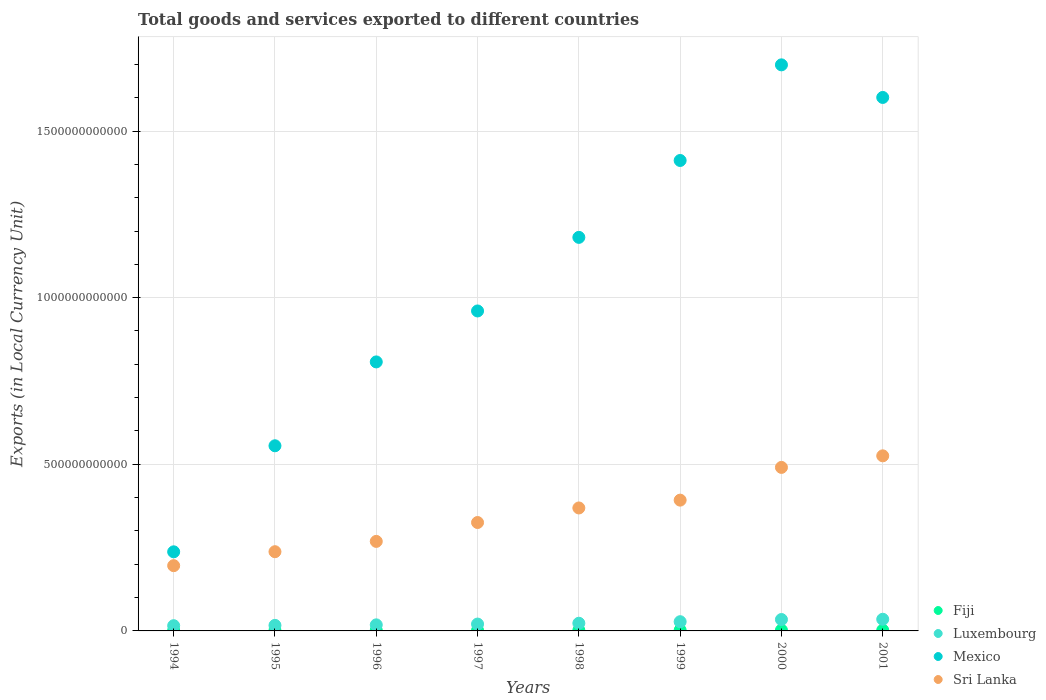How many different coloured dotlines are there?
Give a very brief answer. 4. Is the number of dotlines equal to the number of legend labels?
Keep it short and to the point. Yes. What is the Amount of goods and services exports in Sri Lanka in 2000?
Give a very brief answer. 4.91e+11. Across all years, what is the maximum Amount of goods and services exports in Fiji?
Provide a succinct answer. 2.34e+09. Across all years, what is the minimum Amount of goods and services exports in Fiji?
Make the answer very short. 1.51e+09. In which year was the Amount of goods and services exports in Mexico maximum?
Keep it short and to the point. 2000. In which year was the Amount of goods and services exports in Mexico minimum?
Make the answer very short. 1994. What is the total Amount of goods and services exports in Luxembourg in the graph?
Make the answer very short. 1.91e+11. What is the difference between the Amount of goods and services exports in Luxembourg in 1995 and that in 1999?
Ensure brevity in your answer.  -1.10e+1. What is the difference between the Amount of goods and services exports in Sri Lanka in 1995 and the Amount of goods and services exports in Mexico in 2000?
Provide a short and direct response. -1.46e+12. What is the average Amount of goods and services exports in Fiji per year?
Offer a very short reply. 1.98e+09. In the year 1994, what is the difference between the Amount of goods and services exports in Sri Lanka and Amount of goods and services exports in Mexico?
Your answer should be compact. -4.16e+1. What is the ratio of the Amount of goods and services exports in Mexico in 1996 to that in 2001?
Keep it short and to the point. 0.5. What is the difference between the highest and the second highest Amount of goods and services exports in Sri Lanka?
Provide a short and direct response. 3.47e+1. What is the difference between the highest and the lowest Amount of goods and services exports in Fiji?
Give a very brief answer. 8.28e+08. Is it the case that in every year, the sum of the Amount of goods and services exports in Luxembourg and Amount of goods and services exports in Sri Lanka  is greater than the sum of Amount of goods and services exports in Fiji and Amount of goods and services exports in Mexico?
Your response must be concise. No. Is it the case that in every year, the sum of the Amount of goods and services exports in Luxembourg and Amount of goods and services exports in Mexico  is greater than the Amount of goods and services exports in Sri Lanka?
Your response must be concise. Yes. Does the Amount of goods and services exports in Luxembourg monotonically increase over the years?
Provide a short and direct response. Yes. How many dotlines are there?
Give a very brief answer. 4. What is the difference between two consecutive major ticks on the Y-axis?
Ensure brevity in your answer.  5.00e+11. How many legend labels are there?
Ensure brevity in your answer.  4. What is the title of the graph?
Your answer should be very brief. Total goods and services exported to different countries. What is the label or title of the Y-axis?
Provide a succinct answer. Exports (in Local Currency Unit). What is the Exports (in Local Currency Unit) of Fiji in 1994?
Provide a short and direct response. 1.51e+09. What is the Exports (in Local Currency Unit) in Luxembourg in 1994?
Your answer should be very brief. 1.57e+1. What is the Exports (in Local Currency Unit) of Mexico in 1994?
Ensure brevity in your answer.  2.37e+11. What is the Exports (in Local Currency Unit) of Sri Lanka in 1994?
Your answer should be compact. 1.96e+11. What is the Exports (in Local Currency Unit) in Fiji in 1995?
Your response must be concise. 1.64e+09. What is the Exports (in Local Currency Unit) of Luxembourg in 1995?
Make the answer very short. 1.67e+1. What is the Exports (in Local Currency Unit) in Mexico in 1995?
Make the answer very short. 5.56e+11. What is the Exports (in Local Currency Unit) of Sri Lanka in 1995?
Your answer should be compact. 2.38e+11. What is the Exports (in Local Currency Unit) in Fiji in 1996?
Provide a succinct answer. 1.88e+09. What is the Exports (in Local Currency Unit) in Luxembourg in 1996?
Your response must be concise. 1.82e+1. What is the Exports (in Local Currency Unit) in Mexico in 1996?
Keep it short and to the point. 8.07e+11. What is the Exports (in Local Currency Unit) in Sri Lanka in 1996?
Your answer should be compact. 2.69e+11. What is the Exports (in Local Currency Unit) in Fiji in 1997?
Ensure brevity in your answer.  1.85e+09. What is the Exports (in Local Currency Unit) of Luxembourg in 1997?
Provide a short and direct response. 2.06e+1. What is the Exports (in Local Currency Unit) in Mexico in 1997?
Your answer should be very brief. 9.60e+11. What is the Exports (in Local Currency Unit) of Sri Lanka in 1997?
Give a very brief answer. 3.25e+11. What is the Exports (in Local Currency Unit) of Fiji in 1998?
Ensure brevity in your answer.  2.00e+09. What is the Exports (in Local Currency Unit) in Luxembourg in 1998?
Provide a short and direct response. 2.30e+1. What is the Exports (in Local Currency Unit) of Mexico in 1998?
Your response must be concise. 1.18e+12. What is the Exports (in Local Currency Unit) of Sri Lanka in 1998?
Make the answer very short. 3.69e+11. What is the Exports (in Local Currency Unit) of Fiji in 1999?
Offer a very short reply. 2.33e+09. What is the Exports (in Local Currency Unit) in Luxembourg in 1999?
Give a very brief answer. 2.77e+1. What is the Exports (in Local Currency Unit) of Mexico in 1999?
Provide a short and direct response. 1.41e+12. What is the Exports (in Local Currency Unit) of Sri Lanka in 1999?
Your answer should be compact. 3.92e+11. What is the Exports (in Local Currency Unit) of Fiji in 2000?
Ensure brevity in your answer.  2.34e+09. What is the Exports (in Local Currency Unit) of Luxembourg in 2000?
Ensure brevity in your answer.  3.42e+1. What is the Exports (in Local Currency Unit) in Mexico in 2000?
Ensure brevity in your answer.  1.70e+12. What is the Exports (in Local Currency Unit) of Sri Lanka in 2000?
Make the answer very short. 4.91e+11. What is the Exports (in Local Currency Unit) in Fiji in 2001?
Ensure brevity in your answer.  2.29e+09. What is the Exports (in Local Currency Unit) of Luxembourg in 2001?
Keep it short and to the point. 3.50e+1. What is the Exports (in Local Currency Unit) in Mexico in 2001?
Ensure brevity in your answer.  1.60e+12. What is the Exports (in Local Currency Unit) of Sri Lanka in 2001?
Your response must be concise. 5.25e+11. Across all years, what is the maximum Exports (in Local Currency Unit) of Fiji?
Provide a succinct answer. 2.34e+09. Across all years, what is the maximum Exports (in Local Currency Unit) of Luxembourg?
Offer a terse response. 3.50e+1. Across all years, what is the maximum Exports (in Local Currency Unit) of Mexico?
Provide a succinct answer. 1.70e+12. Across all years, what is the maximum Exports (in Local Currency Unit) in Sri Lanka?
Make the answer very short. 5.25e+11. Across all years, what is the minimum Exports (in Local Currency Unit) in Fiji?
Give a very brief answer. 1.51e+09. Across all years, what is the minimum Exports (in Local Currency Unit) of Luxembourg?
Offer a terse response. 1.57e+1. Across all years, what is the minimum Exports (in Local Currency Unit) of Mexico?
Your answer should be compact. 2.37e+11. Across all years, what is the minimum Exports (in Local Currency Unit) of Sri Lanka?
Keep it short and to the point. 1.96e+11. What is the total Exports (in Local Currency Unit) of Fiji in the graph?
Ensure brevity in your answer.  1.58e+1. What is the total Exports (in Local Currency Unit) in Luxembourg in the graph?
Offer a very short reply. 1.91e+11. What is the total Exports (in Local Currency Unit) of Mexico in the graph?
Give a very brief answer. 8.45e+12. What is the total Exports (in Local Currency Unit) of Sri Lanka in the graph?
Provide a succinct answer. 2.80e+12. What is the difference between the Exports (in Local Currency Unit) of Fiji in 1994 and that in 1995?
Provide a short and direct response. -1.35e+08. What is the difference between the Exports (in Local Currency Unit) of Luxembourg in 1994 and that in 1995?
Make the answer very short. -9.69e+08. What is the difference between the Exports (in Local Currency Unit) of Mexico in 1994 and that in 1995?
Your answer should be very brief. -3.18e+11. What is the difference between the Exports (in Local Currency Unit) in Sri Lanka in 1994 and that in 1995?
Offer a terse response. -4.19e+1. What is the difference between the Exports (in Local Currency Unit) in Fiji in 1994 and that in 1996?
Keep it short and to the point. -3.70e+08. What is the difference between the Exports (in Local Currency Unit) in Luxembourg in 1994 and that in 1996?
Make the answer very short. -2.50e+09. What is the difference between the Exports (in Local Currency Unit) of Mexico in 1994 and that in 1996?
Offer a very short reply. -5.70e+11. What is the difference between the Exports (in Local Currency Unit) in Sri Lanka in 1994 and that in 1996?
Provide a short and direct response. -7.28e+1. What is the difference between the Exports (in Local Currency Unit) of Fiji in 1994 and that in 1997?
Provide a short and direct response. -3.38e+08. What is the difference between the Exports (in Local Currency Unit) of Luxembourg in 1994 and that in 1997?
Give a very brief answer. -4.89e+09. What is the difference between the Exports (in Local Currency Unit) of Mexico in 1994 and that in 1997?
Your response must be concise. -7.23e+11. What is the difference between the Exports (in Local Currency Unit) in Sri Lanka in 1994 and that in 1997?
Offer a very short reply. -1.29e+11. What is the difference between the Exports (in Local Currency Unit) in Fiji in 1994 and that in 1998?
Offer a very short reply. -4.94e+08. What is the difference between the Exports (in Local Currency Unit) in Luxembourg in 1994 and that in 1998?
Give a very brief answer. -7.32e+09. What is the difference between the Exports (in Local Currency Unit) of Mexico in 1994 and that in 1998?
Keep it short and to the point. -9.44e+11. What is the difference between the Exports (in Local Currency Unit) in Sri Lanka in 1994 and that in 1998?
Your response must be concise. -1.73e+11. What is the difference between the Exports (in Local Currency Unit) in Fiji in 1994 and that in 1999?
Give a very brief answer. -8.26e+08. What is the difference between the Exports (in Local Currency Unit) in Luxembourg in 1994 and that in 1999?
Keep it short and to the point. -1.20e+1. What is the difference between the Exports (in Local Currency Unit) of Mexico in 1994 and that in 1999?
Ensure brevity in your answer.  -1.17e+12. What is the difference between the Exports (in Local Currency Unit) in Sri Lanka in 1994 and that in 1999?
Provide a short and direct response. -1.97e+11. What is the difference between the Exports (in Local Currency Unit) in Fiji in 1994 and that in 2000?
Provide a short and direct response. -8.28e+08. What is the difference between the Exports (in Local Currency Unit) in Luxembourg in 1994 and that in 2000?
Make the answer very short. -1.85e+1. What is the difference between the Exports (in Local Currency Unit) in Mexico in 1994 and that in 2000?
Provide a succinct answer. -1.46e+12. What is the difference between the Exports (in Local Currency Unit) in Sri Lanka in 1994 and that in 2000?
Offer a terse response. -2.95e+11. What is the difference between the Exports (in Local Currency Unit) in Fiji in 1994 and that in 2001?
Offer a terse response. -7.85e+08. What is the difference between the Exports (in Local Currency Unit) in Luxembourg in 1994 and that in 2001?
Your answer should be compact. -1.93e+1. What is the difference between the Exports (in Local Currency Unit) in Mexico in 1994 and that in 2001?
Provide a succinct answer. -1.36e+12. What is the difference between the Exports (in Local Currency Unit) of Sri Lanka in 1994 and that in 2001?
Offer a terse response. -3.30e+11. What is the difference between the Exports (in Local Currency Unit) of Fiji in 1995 and that in 1996?
Provide a succinct answer. -2.35e+08. What is the difference between the Exports (in Local Currency Unit) of Luxembourg in 1995 and that in 1996?
Give a very brief answer. -1.53e+09. What is the difference between the Exports (in Local Currency Unit) in Mexico in 1995 and that in 1996?
Offer a terse response. -2.52e+11. What is the difference between the Exports (in Local Currency Unit) of Sri Lanka in 1995 and that in 1996?
Make the answer very short. -3.09e+1. What is the difference between the Exports (in Local Currency Unit) of Fiji in 1995 and that in 1997?
Give a very brief answer. -2.02e+08. What is the difference between the Exports (in Local Currency Unit) of Luxembourg in 1995 and that in 1997?
Provide a succinct answer. -3.92e+09. What is the difference between the Exports (in Local Currency Unit) in Mexico in 1995 and that in 1997?
Your answer should be very brief. -4.05e+11. What is the difference between the Exports (in Local Currency Unit) in Sri Lanka in 1995 and that in 1997?
Keep it short and to the point. -8.76e+1. What is the difference between the Exports (in Local Currency Unit) in Fiji in 1995 and that in 1998?
Offer a very short reply. -3.59e+08. What is the difference between the Exports (in Local Currency Unit) in Luxembourg in 1995 and that in 1998?
Make the answer very short. -6.36e+09. What is the difference between the Exports (in Local Currency Unit) in Mexico in 1995 and that in 1998?
Make the answer very short. -6.25e+11. What is the difference between the Exports (in Local Currency Unit) in Sri Lanka in 1995 and that in 1998?
Provide a succinct answer. -1.31e+11. What is the difference between the Exports (in Local Currency Unit) in Fiji in 1995 and that in 1999?
Your answer should be compact. -6.91e+08. What is the difference between the Exports (in Local Currency Unit) in Luxembourg in 1995 and that in 1999?
Ensure brevity in your answer.  -1.10e+1. What is the difference between the Exports (in Local Currency Unit) in Mexico in 1995 and that in 1999?
Offer a very short reply. -8.56e+11. What is the difference between the Exports (in Local Currency Unit) in Sri Lanka in 1995 and that in 1999?
Ensure brevity in your answer.  -1.55e+11. What is the difference between the Exports (in Local Currency Unit) of Fiji in 1995 and that in 2000?
Provide a succinct answer. -6.93e+08. What is the difference between the Exports (in Local Currency Unit) in Luxembourg in 1995 and that in 2000?
Ensure brevity in your answer.  -1.75e+1. What is the difference between the Exports (in Local Currency Unit) in Mexico in 1995 and that in 2000?
Offer a very short reply. -1.14e+12. What is the difference between the Exports (in Local Currency Unit) of Sri Lanka in 1995 and that in 2000?
Make the answer very short. -2.53e+11. What is the difference between the Exports (in Local Currency Unit) of Fiji in 1995 and that in 2001?
Your response must be concise. -6.50e+08. What is the difference between the Exports (in Local Currency Unit) of Luxembourg in 1995 and that in 2001?
Your answer should be very brief. -1.83e+1. What is the difference between the Exports (in Local Currency Unit) of Mexico in 1995 and that in 2001?
Ensure brevity in your answer.  -1.05e+12. What is the difference between the Exports (in Local Currency Unit) of Sri Lanka in 1995 and that in 2001?
Offer a terse response. -2.88e+11. What is the difference between the Exports (in Local Currency Unit) of Fiji in 1996 and that in 1997?
Keep it short and to the point. 3.26e+07. What is the difference between the Exports (in Local Currency Unit) in Luxembourg in 1996 and that in 1997?
Give a very brief answer. -2.38e+09. What is the difference between the Exports (in Local Currency Unit) in Mexico in 1996 and that in 1997?
Keep it short and to the point. -1.53e+11. What is the difference between the Exports (in Local Currency Unit) in Sri Lanka in 1996 and that in 1997?
Give a very brief answer. -5.66e+1. What is the difference between the Exports (in Local Currency Unit) of Fiji in 1996 and that in 1998?
Your answer should be very brief. -1.24e+08. What is the difference between the Exports (in Local Currency Unit) in Luxembourg in 1996 and that in 1998?
Give a very brief answer. -4.82e+09. What is the difference between the Exports (in Local Currency Unit) of Mexico in 1996 and that in 1998?
Give a very brief answer. -3.74e+11. What is the difference between the Exports (in Local Currency Unit) of Sri Lanka in 1996 and that in 1998?
Ensure brevity in your answer.  -1.00e+11. What is the difference between the Exports (in Local Currency Unit) of Fiji in 1996 and that in 1999?
Make the answer very short. -4.56e+08. What is the difference between the Exports (in Local Currency Unit) in Luxembourg in 1996 and that in 1999?
Your answer should be compact. -9.48e+09. What is the difference between the Exports (in Local Currency Unit) in Mexico in 1996 and that in 1999?
Give a very brief answer. -6.04e+11. What is the difference between the Exports (in Local Currency Unit) in Sri Lanka in 1996 and that in 1999?
Make the answer very short. -1.24e+11. What is the difference between the Exports (in Local Currency Unit) in Fiji in 1996 and that in 2000?
Provide a succinct answer. -4.58e+08. What is the difference between the Exports (in Local Currency Unit) in Luxembourg in 1996 and that in 2000?
Make the answer very short. -1.60e+1. What is the difference between the Exports (in Local Currency Unit) in Mexico in 1996 and that in 2000?
Provide a succinct answer. -8.91e+11. What is the difference between the Exports (in Local Currency Unit) in Sri Lanka in 1996 and that in 2000?
Make the answer very short. -2.22e+11. What is the difference between the Exports (in Local Currency Unit) in Fiji in 1996 and that in 2001?
Ensure brevity in your answer.  -4.15e+08. What is the difference between the Exports (in Local Currency Unit) of Luxembourg in 1996 and that in 2001?
Provide a succinct answer. -1.68e+1. What is the difference between the Exports (in Local Currency Unit) in Mexico in 1996 and that in 2001?
Keep it short and to the point. -7.94e+11. What is the difference between the Exports (in Local Currency Unit) of Sri Lanka in 1996 and that in 2001?
Make the answer very short. -2.57e+11. What is the difference between the Exports (in Local Currency Unit) of Fiji in 1997 and that in 1998?
Keep it short and to the point. -1.56e+08. What is the difference between the Exports (in Local Currency Unit) of Luxembourg in 1997 and that in 1998?
Provide a short and direct response. -2.44e+09. What is the difference between the Exports (in Local Currency Unit) in Mexico in 1997 and that in 1998?
Provide a short and direct response. -2.21e+11. What is the difference between the Exports (in Local Currency Unit) of Sri Lanka in 1997 and that in 1998?
Make the answer very short. -4.37e+1. What is the difference between the Exports (in Local Currency Unit) of Fiji in 1997 and that in 1999?
Your answer should be compact. -4.89e+08. What is the difference between the Exports (in Local Currency Unit) of Luxembourg in 1997 and that in 1999?
Your answer should be compact. -7.10e+09. What is the difference between the Exports (in Local Currency Unit) of Mexico in 1997 and that in 1999?
Provide a succinct answer. -4.52e+11. What is the difference between the Exports (in Local Currency Unit) of Sri Lanka in 1997 and that in 1999?
Ensure brevity in your answer.  -6.71e+1. What is the difference between the Exports (in Local Currency Unit) in Fiji in 1997 and that in 2000?
Keep it short and to the point. -4.90e+08. What is the difference between the Exports (in Local Currency Unit) of Luxembourg in 1997 and that in 2000?
Your answer should be compact. -1.36e+1. What is the difference between the Exports (in Local Currency Unit) in Mexico in 1997 and that in 2000?
Keep it short and to the point. -7.38e+11. What is the difference between the Exports (in Local Currency Unit) in Sri Lanka in 1997 and that in 2000?
Offer a terse response. -1.65e+11. What is the difference between the Exports (in Local Currency Unit) in Fiji in 1997 and that in 2001?
Provide a succinct answer. -4.48e+08. What is the difference between the Exports (in Local Currency Unit) of Luxembourg in 1997 and that in 2001?
Offer a terse response. -1.44e+1. What is the difference between the Exports (in Local Currency Unit) of Mexico in 1997 and that in 2001?
Your answer should be compact. -6.41e+11. What is the difference between the Exports (in Local Currency Unit) of Sri Lanka in 1997 and that in 2001?
Offer a very short reply. -2.00e+11. What is the difference between the Exports (in Local Currency Unit) in Fiji in 1998 and that in 1999?
Provide a succinct answer. -3.33e+08. What is the difference between the Exports (in Local Currency Unit) of Luxembourg in 1998 and that in 1999?
Give a very brief answer. -4.66e+09. What is the difference between the Exports (in Local Currency Unit) of Mexico in 1998 and that in 1999?
Keep it short and to the point. -2.31e+11. What is the difference between the Exports (in Local Currency Unit) of Sri Lanka in 1998 and that in 1999?
Offer a terse response. -2.35e+1. What is the difference between the Exports (in Local Currency Unit) of Fiji in 1998 and that in 2000?
Your answer should be compact. -3.34e+08. What is the difference between the Exports (in Local Currency Unit) in Luxembourg in 1998 and that in 2000?
Provide a short and direct response. -1.12e+1. What is the difference between the Exports (in Local Currency Unit) of Mexico in 1998 and that in 2000?
Give a very brief answer. -5.18e+11. What is the difference between the Exports (in Local Currency Unit) of Sri Lanka in 1998 and that in 2000?
Provide a succinct answer. -1.22e+11. What is the difference between the Exports (in Local Currency Unit) of Fiji in 1998 and that in 2001?
Your response must be concise. -2.92e+08. What is the difference between the Exports (in Local Currency Unit) of Luxembourg in 1998 and that in 2001?
Your answer should be compact. -1.20e+1. What is the difference between the Exports (in Local Currency Unit) in Mexico in 1998 and that in 2001?
Provide a short and direct response. -4.20e+11. What is the difference between the Exports (in Local Currency Unit) of Sri Lanka in 1998 and that in 2001?
Offer a very short reply. -1.56e+11. What is the difference between the Exports (in Local Currency Unit) of Fiji in 1999 and that in 2000?
Keep it short and to the point. -1.50e+06. What is the difference between the Exports (in Local Currency Unit) of Luxembourg in 1999 and that in 2000?
Provide a succinct answer. -6.53e+09. What is the difference between the Exports (in Local Currency Unit) in Mexico in 1999 and that in 2000?
Your answer should be compact. -2.87e+11. What is the difference between the Exports (in Local Currency Unit) in Sri Lanka in 1999 and that in 2000?
Your answer should be compact. -9.82e+1. What is the difference between the Exports (in Local Currency Unit) in Fiji in 1999 and that in 2001?
Keep it short and to the point. 4.12e+07. What is the difference between the Exports (in Local Currency Unit) of Luxembourg in 1999 and that in 2001?
Offer a terse response. -7.30e+09. What is the difference between the Exports (in Local Currency Unit) of Mexico in 1999 and that in 2001?
Ensure brevity in your answer.  -1.89e+11. What is the difference between the Exports (in Local Currency Unit) in Sri Lanka in 1999 and that in 2001?
Provide a short and direct response. -1.33e+11. What is the difference between the Exports (in Local Currency Unit) in Fiji in 2000 and that in 2001?
Give a very brief answer. 4.27e+07. What is the difference between the Exports (in Local Currency Unit) in Luxembourg in 2000 and that in 2001?
Your answer should be compact. -7.67e+08. What is the difference between the Exports (in Local Currency Unit) of Mexico in 2000 and that in 2001?
Offer a very short reply. 9.78e+1. What is the difference between the Exports (in Local Currency Unit) of Sri Lanka in 2000 and that in 2001?
Your response must be concise. -3.47e+1. What is the difference between the Exports (in Local Currency Unit) in Fiji in 1994 and the Exports (in Local Currency Unit) in Luxembourg in 1995?
Give a very brief answer. -1.52e+1. What is the difference between the Exports (in Local Currency Unit) in Fiji in 1994 and the Exports (in Local Currency Unit) in Mexico in 1995?
Your answer should be compact. -5.54e+11. What is the difference between the Exports (in Local Currency Unit) of Fiji in 1994 and the Exports (in Local Currency Unit) of Sri Lanka in 1995?
Your answer should be compact. -2.36e+11. What is the difference between the Exports (in Local Currency Unit) in Luxembourg in 1994 and the Exports (in Local Currency Unit) in Mexico in 1995?
Provide a short and direct response. -5.40e+11. What is the difference between the Exports (in Local Currency Unit) in Luxembourg in 1994 and the Exports (in Local Currency Unit) in Sri Lanka in 1995?
Offer a terse response. -2.22e+11. What is the difference between the Exports (in Local Currency Unit) of Mexico in 1994 and the Exports (in Local Currency Unit) of Sri Lanka in 1995?
Give a very brief answer. -3.53e+08. What is the difference between the Exports (in Local Currency Unit) in Fiji in 1994 and the Exports (in Local Currency Unit) in Luxembourg in 1996?
Your answer should be compact. -1.67e+1. What is the difference between the Exports (in Local Currency Unit) in Fiji in 1994 and the Exports (in Local Currency Unit) in Mexico in 1996?
Ensure brevity in your answer.  -8.06e+11. What is the difference between the Exports (in Local Currency Unit) in Fiji in 1994 and the Exports (in Local Currency Unit) in Sri Lanka in 1996?
Provide a short and direct response. -2.67e+11. What is the difference between the Exports (in Local Currency Unit) in Luxembourg in 1994 and the Exports (in Local Currency Unit) in Mexico in 1996?
Your response must be concise. -7.92e+11. What is the difference between the Exports (in Local Currency Unit) in Luxembourg in 1994 and the Exports (in Local Currency Unit) in Sri Lanka in 1996?
Provide a succinct answer. -2.53e+11. What is the difference between the Exports (in Local Currency Unit) of Mexico in 1994 and the Exports (in Local Currency Unit) of Sri Lanka in 1996?
Offer a terse response. -3.13e+1. What is the difference between the Exports (in Local Currency Unit) in Fiji in 1994 and the Exports (in Local Currency Unit) in Luxembourg in 1997?
Your answer should be compact. -1.91e+1. What is the difference between the Exports (in Local Currency Unit) of Fiji in 1994 and the Exports (in Local Currency Unit) of Mexico in 1997?
Keep it short and to the point. -9.59e+11. What is the difference between the Exports (in Local Currency Unit) in Fiji in 1994 and the Exports (in Local Currency Unit) in Sri Lanka in 1997?
Offer a terse response. -3.24e+11. What is the difference between the Exports (in Local Currency Unit) in Luxembourg in 1994 and the Exports (in Local Currency Unit) in Mexico in 1997?
Offer a very short reply. -9.44e+11. What is the difference between the Exports (in Local Currency Unit) in Luxembourg in 1994 and the Exports (in Local Currency Unit) in Sri Lanka in 1997?
Your answer should be very brief. -3.10e+11. What is the difference between the Exports (in Local Currency Unit) of Mexico in 1994 and the Exports (in Local Currency Unit) of Sri Lanka in 1997?
Your response must be concise. -8.79e+1. What is the difference between the Exports (in Local Currency Unit) in Fiji in 1994 and the Exports (in Local Currency Unit) in Luxembourg in 1998?
Provide a succinct answer. -2.15e+1. What is the difference between the Exports (in Local Currency Unit) of Fiji in 1994 and the Exports (in Local Currency Unit) of Mexico in 1998?
Give a very brief answer. -1.18e+12. What is the difference between the Exports (in Local Currency Unit) of Fiji in 1994 and the Exports (in Local Currency Unit) of Sri Lanka in 1998?
Your response must be concise. -3.67e+11. What is the difference between the Exports (in Local Currency Unit) of Luxembourg in 1994 and the Exports (in Local Currency Unit) of Mexico in 1998?
Offer a very short reply. -1.17e+12. What is the difference between the Exports (in Local Currency Unit) in Luxembourg in 1994 and the Exports (in Local Currency Unit) in Sri Lanka in 1998?
Your answer should be very brief. -3.53e+11. What is the difference between the Exports (in Local Currency Unit) of Mexico in 1994 and the Exports (in Local Currency Unit) of Sri Lanka in 1998?
Keep it short and to the point. -1.32e+11. What is the difference between the Exports (in Local Currency Unit) in Fiji in 1994 and the Exports (in Local Currency Unit) in Luxembourg in 1999?
Your answer should be very brief. -2.62e+1. What is the difference between the Exports (in Local Currency Unit) of Fiji in 1994 and the Exports (in Local Currency Unit) of Mexico in 1999?
Provide a short and direct response. -1.41e+12. What is the difference between the Exports (in Local Currency Unit) in Fiji in 1994 and the Exports (in Local Currency Unit) in Sri Lanka in 1999?
Provide a short and direct response. -3.91e+11. What is the difference between the Exports (in Local Currency Unit) in Luxembourg in 1994 and the Exports (in Local Currency Unit) in Mexico in 1999?
Offer a terse response. -1.40e+12. What is the difference between the Exports (in Local Currency Unit) of Luxembourg in 1994 and the Exports (in Local Currency Unit) of Sri Lanka in 1999?
Your response must be concise. -3.77e+11. What is the difference between the Exports (in Local Currency Unit) of Mexico in 1994 and the Exports (in Local Currency Unit) of Sri Lanka in 1999?
Provide a short and direct response. -1.55e+11. What is the difference between the Exports (in Local Currency Unit) in Fiji in 1994 and the Exports (in Local Currency Unit) in Luxembourg in 2000?
Offer a very short reply. -3.27e+1. What is the difference between the Exports (in Local Currency Unit) of Fiji in 1994 and the Exports (in Local Currency Unit) of Mexico in 2000?
Offer a terse response. -1.70e+12. What is the difference between the Exports (in Local Currency Unit) of Fiji in 1994 and the Exports (in Local Currency Unit) of Sri Lanka in 2000?
Offer a very short reply. -4.89e+11. What is the difference between the Exports (in Local Currency Unit) in Luxembourg in 1994 and the Exports (in Local Currency Unit) in Mexico in 2000?
Ensure brevity in your answer.  -1.68e+12. What is the difference between the Exports (in Local Currency Unit) in Luxembourg in 1994 and the Exports (in Local Currency Unit) in Sri Lanka in 2000?
Provide a succinct answer. -4.75e+11. What is the difference between the Exports (in Local Currency Unit) of Mexico in 1994 and the Exports (in Local Currency Unit) of Sri Lanka in 2000?
Your answer should be very brief. -2.53e+11. What is the difference between the Exports (in Local Currency Unit) in Fiji in 1994 and the Exports (in Local Currency Unit) in Luxembourg in 2001?
Keep it short and to the point. -3.35e+1. What is the difference between the Exports (in Local Currency Unit) of Fiji in 1994 and the Exports (in Local Currency Unit) of Mexico in 2001?
Your answer should be compact. -1.60e+12. What is the difference between the Exports (in Local Currency Unit) of Fiji in 1994 and the Exports (in Local Currency Unit) of Sri Lanka in 2001?
Keep it short and to the point. -5.24e+11. What is the difference between the Exports (in Local Currency Unit) in Luxembourg in 1994 and the Exports (in Local Currency Unit) in Mexico in 2001?
Make the answer very short. -1.59e+12. What is the difference between the Exports (in Local Currency Unit) of Luxembourg in 1994 and the Exports (in Local Currency Unit) of Sri Lanka in 2001?
Make the answer very short. -5.10e+11. What is the difference between the Exports (in Local Currency Unit) of Mexico in 1994 and the Exports (in Local Currency Unit) of Sri Lanka in 2001?
Provide a succinct answer. -2.88e+11. What is the difference between the Exports (in Local Currency Unit) in Fiji in 1995 and the Exports (in Local Currency Unit) in Luxembourg in 1996?
Ensure brevity in your answer.  -1.66e+1. What is the difference between the Exports (in Local Currency Unit) of Fiji in 1995 and the Exports (in Local Currency Unit) of Mexico in 1996?
Keep it short and to the point. -8.06e+11. What is the difference between the Exports (in Local Currency Unit) in Fiji in 1995 and the Exports (in Local Currency Unit) in Sri Lanka in 1996?
Your answer should be compact. -2.67e+11. What is the difference between the Exports (in Local Currency Unit) of Luxembourg in 1995 and the Exports (in Local Currency Unit) of Mexico in 1996?
Offer a terse response. -7.91e+11. What is the difference between the Exports (in Local Currency Unit) of Luxembourg in 1995 and the Exports (in Local Currency Unit) of Sri Lanka in 1996?
Ensure brevity in your answer.  -2.52e+11. What is the difference between the Exports (in Local Currency Unit) in Mexico in 1995 and the Exports (in Local Currency Unit) in Sri Lanka in 1996?
Make the answer very short. 2.87e+11. What is the difference between the Exports (in Local Currency Unit) of Fiji in 1995 and the Exports (in Local Currency Unit) of Luxembourg in 1997?
Provide a succinct answer. -1.89e+1. What is the difference between the Exports (in Local Currency Unit) in Fiji in 1995 and the Exports (in Local Currency Unit) in Mexico in 1997?
Make the answer very short. -9.58e+11. What is the difference between the Exports (in Local Currency Unit) in Fiji in 1995 and the Exports (in Local Currency Unit) in Sri Lanka in 1997?
Provide a short and direct response. -3.24e+11. What is the difference between the Exports (in Local Currency Unit) in Luxembourg in 1995 and the Exports (in Local Currency Unit) in Mexico in 1997?
Keep it short and to the point. -9.43e+11. What is the difference between the Exports (in Local Currency Unit) of Luxembourg in 1995 and the Exports (in Local Currency Unit) of Sri Lanka in 1997?
Your response must be concise. -3.09e+11. What is the difference between the Exports (in Local Currency Unit) in Mexico in 1995 and the Exports (in Local Currency Unit) in Sri Lanka in 1997?
Provide a succinct answer. 2.30e+11. What is the difference between the Exports (in Local Currency Unit) of Fiji in 1995 and the Exports (in Local Currency Unit) of Luxembourg in 1998?
Your response must be concise. -2.14e+1. What is the difference between the Exports (in Local Currency Unit) in Fiji in 1995 and the Exports (in Local Currency Unit) in Mexico in 1998?
Keep it short and to the point. -1.18e+12. What is the difference between the Exports (in Local Currency Unit) of Fiji in 1995 and the Exports (in Local Currency Unit) of Sri Lanka in 1998?
Give a very brief answer. -3.67e+11. What is the difference between the Exports (in Local Currency Unit) of Luxembourg in 1995 and the Exports (in Local Currency Unit) of Mexico in 1998?
Your response must be concise. -1.16e+12. What is the difference between the Exports (in Local Currency Unit) of Luxembourg in 1995 and the Exports (in Local Currency Unit) of Sri Lanka in 1998?
Offer a very short reply. -3.52e+11. What is the difference between the Exports (in Local Currency Unit) in Mexico in 1995 and the Exports (in Local Currency Unit) in Sri Lanka in 1998?
Offer a very short reply. 1.87e+11. What is the difference between the Exports (in Local Currency Unit) in Fiji in 1995 and the Exports (in Local Currency Unit) in Luxembourg in 1999?
Provide a succinct answer. -2.60e+1. What is the difference between the Exports (in Local Currency Unit) of Fiji in 1995 and the Exports (in Local Currency Unit) of Mexico in 1999?
Offer a very short reply. -1.41e+12. What is the difference between the Exports (in Local Currency Unit) in Fiji in 1995 and the Exports (in Local Currency Unit) in Sri Lanka in 1999?
Your answer should be very brief. -3.91e+11. What is the difference between the Exports (in Local Currency Unit) of Luxembourg in 1995 and the Exports (in Local Currency Unit) of Mexico in 1999?
Give a very brief answer. -1.39e+12. What is the difference between the Exports (in Local Currency Unit) in Luxembourg in 1995 and the Exports (in Local Currency Unit) in Sri Lanka in 1999?
Your response must be concise. -3.76e+11. What is the difference between the Exports (in Local Currency Unit) in Mexico in 1995 and the Exports (in Local Currency Unit) in Sri Lanka in 1999?
Your answer should be very brief. 1.63e+11. What is the difference between the Exports (in Local Currency Unit) of Fiji in 1995 and the Exports (in Local Currency Unit) of Luxembourg in 2000?
Make the answer very short. -3.26e+1. What is the difference between the Exports (in Local Currency Unit) in Fiji in 1995 and the Exports (in Local Currency Unit) in Mexico in 2000?
Your answer should be compact. -1.70e+12. What is the difference between the Exports (in Local Currency Unit) in Fiji in 1995 and the Exports (in Local Currency Unit) in Sri Lanka in 2000?
Keep it short and to the point. -4.89e+11. What is the difference between the Exports (in Local Currency Unit) in Luxembourg in 1995 and the Exports (in Local Currency Unit) in Mexico in 2000?
Provide a short and direct response. -1.68e+12. What is the difference between the Exports (in Local Currency Unit) in Luxembourg in 1995 and the Exports (in Local Currency Unit) in Sri Lanka in 2000?
Offer a very short reply. -4.74e+11. What is the difference between the Exports (in Local Currency Unit) in Mexico in 1995 and the Exports (in Local Currency Unit) in Sri Lanka in 2000?
Offer a terse response. 6.49e+1. What is the difference between the Exports (in Local Currency Unit) of Fiji in 1995 and the Exports (in Local Currency Unit) of Luxembourg in 2001?
Your answer should be compact. -3.33e+1. What is the difference between the Exports (in Local Currency Unit) of Fiji in 1995 and the Exports (in Local Currency Unit) of Mexico in 2001?
Give a very brief answer. -1.60e+12. What is the difference between the Exports (in Local Currency Unit) of Fiji in 1995 and the Exports (in Local Currency Unit) of Sri Lanka in 2001?
Provide a short and direct response. -5.24e+11. What is the difference between the Exports (in Local Currency Unit) of Luxembourg in 1995 and the Exports (in Local Currency Unit) of Mexico in 2001?
Provide a succinct answer. -1.58e+12. What is the difference between the Exports (in Local Currency Unit) of Luxembourg in 1995 and the Exports (in Local Currency Unit) of Sri Lanka in 2001?
Keep it short and to the point. -5.09e+11. What is the difference between the Exports (in Local Currency Unit) of Mexico in 1995 and the Exports (in Local Currency Unit) of Sri Lanka in 2001?
Offer a very short reply. 3.02e+1. What is the difference between the Exports (in Local Currency Unit) in Fiji in 1996 and the Exports (in Local Currency Unit) in Luxembourg in 1997?
Provide a succinct answer. -1.87e+1. What is the difference between the Exports (in Local Currency Unit) of Fiji in 1996 and the Exports (in Local Currency Unit) of Mexico in 1997?
Give a very brief answer. -9.58e+11. What is the difference between the Exports (in Local Currency Unit) in Fiji in 1996 and the Exports (in Local Currency Unit) in Sri Lanka in 1997?
Your answer should be compact. -3.23e+11. What is the difference between the Exports (in Local Currency Unit) of Luxembourg in 1996 and the Exports (in Local Currency Unit) of Mexico in 1997?
Ensure brevity in your answer.  -9.42e+11. What is the difference between the Exports (in Local Currency Unit) in Luxembourg in 1996 and the Exports (in Local Currency Unit) in Sri Lanka in 1997?
Provide a short and direct response. -3.07e+11. What is the difference between the Exports (in Local Currency Unit) of Mexico in 1996 and the Exports (in Local Currency Unit) of Sri Lanka in 1997?
Keep it short and to the point. 4.82e+11. What is the difference between the Exports (in Local Currency Unit) of Fiji in 1996 and the Exports (in Local Currency Unit) of Luxembourg in 1998?
Your response must be concise. -2.11e+1. What is the difference between the Exports (in Local Currency Unit) in Fiji in 1996 and the Exports (in Local Currency Unit) in Mexico in 1998?
Keep it short and to the point. -1.18e+12. What is the difference between the Exports (in Local Currency Unit) of Fiji in 1996 and the Exports (in Local Currency Unit) of Sri Lanka in 1998?
Keep it short and to the point. -3.67e+11. What is the difference between the Exports (in Local Currency Unit) of Luxembourg in 1996 and the Exports (in Local Currency Unit) of Mexico in 1998?
Keep it short and to the point. -1.16e+12. What is the difference between the Exports (in Local Currency Unit) of Luxembourg in 1996 and the Exports (in Local Currency Unit) of Sri Lanka in 1998?
Your answer should be compact. -3.51e+11. What is the difference between the Exports (in Local Currency Unit) in Mexico in 1996 and the Exports (in Local Currency Unit) in Sri Lanka in 1998?
Your answer should be compact. 4.38e+11. What is the difference between the Exports (in Local Currency Unit) of Fiji in 1996 and the Exports (in Local Currency Unit) of Luxembourg in 1999?
Make the answer very short. -2.58e+1. What is the difference between the Exports (in Local Currency Unit) of Fiji in 1996 and the Exports (in Local Currency Unit) of Mexico in 1999?
Your answer should be compact. -1.41e+12. What is the difference between the Exports (in Local Currency Unit) of Fiji in 1996 and the Exports (in Local Currency Unit) of Sri Lanka in 1999?
Make the answer very short. -3.91e+11. What is the difference between the Exports (in Local Currency Unit) in Luxembourg in 1996 and the Exports (in Local Currency Unit) in Mexico in 1999?
Provide a succinct answer. -1.39e+12. What is the difference between the Exports (in Local Currency Unit) of Luxembourg in 1996 and the Exports (in Local Currency Unit) of Sri Lanka in 1999?
Provide a succinct answer. -3.74e+11. What is the difference between the Exports (in Local Currency Unit) in Mexico in 1996 and the Exports (in Local Currency Unit) in Sri Lanka in 1999?
Your response must be concise. 4.15e+11. What is the difference between the Exports (in Local Currency Unit) of Fiji in 1996 and the Exports (in Local Currency Unit) of Luxembourg in 2000?
Give a very brief answer. -3.23e+1. What is the difference between the Exports (in Local Currency Unit) of Fiji in 1996 and the Exports (in Local Currency Unit) of Mexico in 2000?
Give a very brief answer. -1.70e+12. What is the difference between the Exports (in Local Currency Unit) of Fiji in 1996 and the Exports (in Local Currency Unit) of Sri Lanka in 2000?
Offer a very short reply. -4.89e+11. What is the difference between the Exports (in Local Currency Unit) of Luxembourg in 1996 and the Exports (in Local Currency Unit) of Mexico in 2000?
Make the answer very short. -1.68e+12. What is the difference between the Exports (in Local Currency Unit) of Luxembourg in 1996 and the Exports (in Local Currency Unit) of Sri Lanka in 2000?
Offer a very short reply. -4.72e+11. What is the difference between the Exports (in Local Currency Unit) in Mexico in 1996 and the Exports (in Local Currency Unit) in Sri Lanka in 2000?
Ensure brevity in your answer.  3.17e+11. What is the difference between the Exports (in Local Currency Unit) of Fiji in 1996 and the Exports (in Local Currency Unit) of Luxembourg in 2001?
Offer a very short reply. -3.31e+1. What is the difference between the Exports (in Local Currency Unit) in Fiji in 1996 and the Exports (in Local Currency Unit) in Mexico in 2001?
Make the answer very short. -1.60e+12. What is the difference between the Exports (in Local Currency Unit) in Fiji in 1996 and the Exports (in Local Currency Unit) in Sri Lanka in 2001?
Your answer should be very brief. -5.24e+11. What is the difference between the Exports (in Local Currency Unit) of Luxembourg in 1996 and the Exports (in Local Currency Unit) of Mexico in 2001?
Your response must be concise. -1.58e+12. What is the difference between the Exports (in Local Currency Unit) of Luxembourg in 1996 and the Exports (in Local Currency Unit) of Sri Lanka in 2001?
Provide a succinct answer. -5.07e+11. What is the difference between the Exports (in Local Currency Unit) in Mexico in 1996 and the Exports (in Local Currency Unit) in Sri Lanka in 2001?
Keep it short and to the point. 2.82e+11. What is the difference between the Exports (in Local Currency Unit) in Fiji in 1997 and the Exports (in Local Currency Unit) in Luxembourg in 1998?
Offer a terse response. -2.12e+1. What is the difference between the Exports (in Local Currency Unit) of Fiji in 1997 and the Exports (in Local Currency Unit) of Mexico in 1998?
Offer a very short reply. -1.18e+12. What is the difference between the Exports (in Local Currency Unit) of Fiji in 1997 and the Exports (in Local Currency Unit) of Sri Lanka in 1998?
Offer a very short reply. -3.67e+11. What is the difference between the Exports (in Local Currency Unit) in Luxembourg in 1997 and the Exports (in Local Currency Unit) in Mexico in 1998?
Offer a very short reply. -1.16e+12. What is the difference between the Exports (in Local Currency Unit) of Luxembourg in 1997 and the Exports (in Local Currency Unit) of Sri Lanka in 1998?
Provide a short and direct response. -3.48e+11. What is the difference between the Exports (in Local Currency Unit) of Mexico in 1997 and the Exports (in Local Currency Unit) of Sri Lanka in 1998?
Your answer should be very brief. 5.91e+11. What is the difference between the Exports (in Local Currency Unit) of Fiji in 1997 and the Exports (in Local Currency Unit) of Luxembourg in 1999?
Keep it short and to the point. -2.58e+1. What is the difference between the Exports (in Local Currency Unit) in Fiji in 1997 and the Exports (in Local Currency Unit) in Mexico in 1999?
Give a very brief answer. -1.41e+12. What is the difference between the Exports (in Local Currency Unit) of Fiji in 1997 and the Exports (in Local Currency Unit) of Sri Lanka in 1999?
Make the answer very short. -3.91e+11. What is the difference between the Exports (in Local Currency Unit) in Luxembourg in 1997 and the Exports (in Local Currency Unit) in Mexico in 1999?
Ensure brevity in your answer.  -1.39e+12. What is the difference between the Exports (in Local Currency Unit) in Luxembourg in 1997 and the Exports (in Local Currency Unit) in Sri Lanka in 1999?
Keep it short and to the point. -3.72e+11. What is the difference between the Exports (in Local Currency Unit) in Mexico in 1997 and the Exports (in Local Currency Unit) in Sri Lanka in 1999?
Provide a short and direct response. 5.68e+11. What is the difference between the Exports (in Local Currency Unit) of Fiji in 1997 and the Exports (in Local Currency Unit) of Luxembourg in 2000?
Your response must be concise. -3.24e+1. What is the difference between the Exports (in Local Currency Unit) of Fiji in 1997 and the Exports (in Local Currency Unit) of Mexico in 2000?
Provide a short and direct response. -1.70e+12. What is the difference between the Exports (in Local Currency Unit) in Fiji in 1997 and the Exports (in Local Currency Unit) in Sri Lanka in 2000?
Keep it short and to the point. -4.89e+11. What is the difference between the Exports (in Local Currency Unit) in Luxembourg in 1997 and the Exports (in Local Currency Unit) in Mexico in 2000?
Make the answer very short. -1.68e+12. What is the difference between the Exports (in Local Currency Unit) in Luxembourg in 1997 and the Exports (in Local Currency Unit) in Sri Lanka in 2000?
Offer a very short reply. -4.70e+11. What is the difference between the Exports (in Local Currency Unit) in Mexico in 1997 and the Exports (in Local Currency Unit) in Sri Lanka in 2000?
Your answer should be very brief. 4.69e+11. What is the difference between the Exports (in Local Currency Unit) of Fiji in 1997 and the Exports (in Local Currency Unit) of Luxembourg in 2001?
Your answer should be very brief. -3.31e+1. What is the difference between the Exports (in Local Currency Unit) of Fiji in 1997 and the Exports (in Local Currency Unit) of Mexico in 2001?
Ensure brevity in your answer.  -1.60e+12. What is the difference between the Exports (in Local Currency Unit) in Fiji in 1997 and the Exports (in Local Currency Unit) in Sri Lanka in 2001?
Keep it short and to the point. -5.24e+11. What is the difference between the Exports (in Local Currency Unit) of Luxembourg in 1997 and the Exports (in Local Currency Unit) of Mexico in 2001?
Your response must be concise. -1.58e+12. What is the difference between the Exports (in Local Currency Unit) in Luxembourg in 1997 and the Exports (in Local Currency Unit) in Sri Lanka in 2001?
Keep it short and to the point. -5.05e+11. What is the difference between the Exports (in Local Currency Unit) in Mexico in 1997 and the Exports (in Local Currency Unit) in Sri Lanka in 2001?
Ensure brevity in your answer.  4.35e+11. What is the difference between the Exports (in Local Currency Unit) of Fiji in 1998 and the Exports (in Local Currency Unit) of Luxembourg in 1999?
Offer a terse response. -2.57e+1. What is the difference between the Exports (in Local Currency Unit) of Fiji in 1998 and the Exports (in Local Currency Unit) of Mexico in 1999?
Keep it short and to the point. -1.41e+12. What is the difference between the Exports (in Local Currency Unit) of Fiji in 1998 and the Exports (in Local Currency Unit) of Sri Lanka in 1999?
Offer a terse response. -3.90e+11. What is the difference between the Exports (in Local Currency Unit) of Luxembourg in 1998 and the Exports (in Local Currency Unit) of Mexico in 1999?
Give a very brief answer. -1.39e+12. What is the difference between the Exports (in Local Currency Unit) in Luxembourg in 1998 and the Exports (in Local Currency Unit) in Sri Lanka in 1999?
Your answer should be very brief. -3.69e+11. What is the difference between the Exports (in Local Currency Unit) in Mexico in 1998 and the Exports (in Local Currency Unit) in Sri Lanka in 1999?
Offer a terse response. 7.89e+11. What is the difference between the Exports (in Local Currency Unit) of Fiji in 1998 and the Exports (in Local Currency Unit) of Luxembourg in 2000?
Offer a terse response. -3.22e+1. What is the difference between the Exports (in Local Currency Unit) of Fiji in 1998 and the Exports (in Local Currency Unit) of Mexico in 2000?
Keep it short and to the point. -1.70e+12. What is the difference between the Exports (in Local Currency Unit) in Fiji in 1998 and the Exports (in Local Currency Unit) in Sri Lanka in 2000?
Provide a succinct answer. -4.89e+11. What is the difference between the Exports (in Local Currency Unit) of Luxembourg in 1998 and the Exports (in Local Currency Unit) of Mexico in 2000?
Make the answer very short. -1.68e+12. What is the difference between the Exports (in Local Currency Unit) of Luxembourg in 1998 and the Exports (in Local Currency Unit) of Sri Lanka in 2000?
Offer a terse response. -4.68e+11. What is the difference between the Exports (in Local Currency Unit) in Mexico in 1998 and the Exports (in Local Currency Unit) in Sri Lanka in 2000?
Your answer should be very brief. 6.90e+11. What is the difference between the Exports (in Local Currency Unit) of Fiji in 1998 and the Exports (in Local Currency Unit) of Luxembourg in 2001?
Your response must be concise. -3.30e+1. What is the difference between the Exports (in Local Currency Unit) in Fiji in 1998 and the Exports (in Local Currency Unit) in Mexico in 2001?
Provide a succinct answer. -1.60e+12. What is the difference between the Exports (in Local Currency Unit) in Fiji in 1998 and the Exports (in Local Currency Unit) in Sri Lanka in 2001?
Offer a terse response. -5.23e+11. What is the difference between the Exports (in Local Currency Unit) of Luxembourg in 1998 and the Exports (in Local Currency Unit) of Mexico in 2001?
Offer a very short reply. -1.58e+12. What is the difference between the Exports (in Local Currency Unit) of Luxembourg in 1998 and the Exports (in Local Currency Unit) of Sri Lanka in 2001?
Provide a short and direct response. -5.02e+11. What is the difference between the Exports (in Local Currency Unit) of Mexico in 1998 and the Exports (in Local Currency Unit) of Sri Lanka in 2001?
Give a very brief answer. 6.56e+11. What is the difference between the Exports (in Local Currency Unit) in Fiji in 1999 and the Exports (in Local Currency Unit) in Luxembourg in 2000?
Your response must be concise. -3.19e+1. What is the difference between the Exports (in Local Currency Unit) of Fiji in 1999 and the Exports (in Local Currency Unit) of Mexico in 2000?
Provide a succinct answer. -1.70e+12. What is the difference between the Exports (in Local Currency Unit) of Fiji in 1999 and the Exports (in Local Currency Unit) of Sri Lanka in 2000?
Provide a succinct answer. -4.88e+11. What is the difference between the Exports (in Local Currency Unit) of Luxembourg in 1999 and the Exports (in Local Currency Unit) of Mexico in 2000?
Provide a short and direct response. -1.67e+12. What is the difference between the Exports (in Local Currency Unit) in Luxembourg in 1999 and the Exports (in Local Currency Unit) in Sri Lanka in 2000?
Provide a short and direct response. -4.63e+11. What is the difference between the Exports (in Local Currency Unit) of Mexico in 1999 and the Exports (in Local Currency Unit) of Sri Lanka in 2000?
Offer a terse response. 9.21e+11. What is the difference between the Exports (in Local Currency Unit) in Fiji in 1999 and the Exports (in Local Currency Unit) in Luxembourg in 2001?
Your answer should be very brief. -3.26e+1. What is the difference between the Exports (in Local Currency Unit) of Fiji in 1999 and the Exports (in Local Currency Unit) of Mexico in 2001?
Keep it short and to the point. -1.60e+12. What is the difference between the Exports (in Local Currency Unit) in Fiji in 1999 and the Exports (in Local Currency Unit) in Sri Lanka in 2001?
Give a very brief answer. -5.23e+11. What is the difference between the Exports (in Local Currency Unit) of Luxembourg in 1999 and the Exports (in Local Currency Unit) of Mexico in 2001?
Make the answer very short. -1.57e+12. What is the difference between the Exports (in Local Currency Unit) of Luxembourg in 1999 and the Exports (in Local Currency Unit) of Sri Lanka in 2001?
Your answer should be very brief. -4.98e+11. What is the difference between the Exports (in Local Currency Unit) of Mexico in 1999 and the Exports (in Local Currency Unit) of Sri Lanka in 2001?
Provide a succinct answer. 8.86e+11. What is the difference between the Exports (in Local Currency Unit) in Fiji in 2000 and the Exports (in Local Currency Unit) in Luxembourg in 2001?
Your answer should be compact. -3.26e+1. What is the difference between the Exports (in Local Currency Unit) of Fiji in 2000 and the Exports (in Local Currency Unit) of Mexico in 2001?
Ensure brevity in your answer.  -1.60e+12. What is the difference between the Exports (in Local Currency Unit) of Fiji in 2000 and the Exports (in Local Currency Unit) of Sri Lanka in 2001?
Provide a short and direct response. -5.23e+11. What is the difference between the Exports (in Local Currency Unit) in Luxembourg in 2000 and the Exports (in Local Currency Unit) in Mexico in 2001?
Keep it short and to the point. -1.57e+12. What is the difference between the Exports (in Local Currency Unit) of Luxembourg in 2000 and the Exports (in Local Currency Unit) of Sri Lanka in 2001?
Offer a terse response. -4.91e+11. What is the difference between the Exports (in Local Currency Unit) in Mexico in 2000 and the Exports (in Local Currency Unit) in Sri Lanka in 2001?
Give a very brief answer. 1.17e+12. What is the average Exports (in Local Currency Unit) in Fiji per year?
Make the answer very short. 1.98e+09. What is the average Exports (in Local Currency Unit) of Luxembourg per year?
Give a very brief answer. 2.39e+1. What is the average Exports (in Local Currency Unit) of Mexico per year?
Your response must be concise. 1.06e+12. What is the average Exports (in Local Currency Unit) in Sri Lanka per year?
Your answer should be very brief. 3.51e+11. In the year 1994, what is the difference between the Exports (in Local Currency Unit) in Fiji and Exports (in Local Currency Unit) in Luxembourg?
Offer a terse response. -1.42e+1. In the year 1994, what is the difference between the Exports (in Local Currency Unit) of Fiji and Exports (in Local Currency Unit) of Mexico?
Your answer should be very brief. -2.36e+11. In the year 1994, what is the difference between the Exports (in Local Currency Unit) in Fiji and Exports (in Local Currency Unit) in Sri Lanka?
Offer a terse response. -1.94e+11. In the year 1994, what is the difference between the Exports (in Local Currency Unit) of Luxembourg and Exports (in Local Currency Unit) of Mexico?
Make the answer very short. -2.22e+11. In the year 1994, what is the difference between the Exports (in Local Currency Unit) of Luxembourg and Exports (in Local Currency Unit) of Sri Lanka?
Provide a succinct answer. -1.80e+11. In the year 1994, what is the difference between the Exports (in Local Currency Unit) of Mexico and Exports (in Local Currency Unit) of Sri Lanka?
Make the answer very short. 4.16e+1. In the year 1995, what is the difference between the Exports (in Local Currency Unit) of Fiji and Exports (in Local Currency Unit) of Luxembourg?
Give a very brief answer. -1.50e+1. In the year 1995, what is the difference between the Exports (in Local Currency Unit) of Fiji and Exports (in Local Currency Unit) of Mexico?
Ensure brevity in your answer.  -5.54e+11. In the year 1995, what is the difference between the Exports (in Local Currency Unit) in Fiji and Exports (in Local Currency Unit) in Sri Lanka?
Offer a very short reply. -2.36e+11. In the year 1995, what is the difference between the Exports (in Local Currency Unit) of Luxembourg and Exports (in Local Currency Unit) of Mexico?
Make the answer very short. -5.39e+11. In the year 1995, what is the difference between the Exports (in Local Currency Unit) of Luxembourg and Exports (in Local Currency Unit) of Sri Lanka?
Ensure brevity in your answer.  -2.21e+11. In the year 1995, what is the difference between the Exports (in Local Currency Unit) in Mexico and Exports (in Local Currency Unit) in Sri Lanka?
Make the answer very short. 3.18e+11. In the year 1996, what is the difference between the Exports (in Local Currency Unit) in Fiji and Exports (in Local Currency Unit) in Luxembourg?
Ensure brevity in your answer.  -1.63e+1. In the year 1996, what is the difference between the Exports (in Local Currency Unit) of Fiji and Exports (in Local Currency Unit) of Mexico?
Provide a short and direct response. -8.05e+11. In the year 1996, what is the difference between the Exports (in Local Currency Unit) in Fiji and Exports (in Local Currency Unit) in Sri Lanka?
Your answer should be compact. -2.67e+11. In the year 1996, what is the difference between the Exports (in Local Currency Unit) of Luxembourg and Exports (in Local Currency Unit) of Mexico?
Provide a short and direct response. -7.89e+11. In the year 1996, what is the difference between the Exports (in Local Currency Unit) of Luxembourg and Exports (in Local Currency Unit) of Sri Lanka?
Your answer should be compact. -2.50e+11. In the year 1996, what is the difference between the Exports (in Local Currency Unit) in Mexico and Exports (in Local Currency Unit) in Sri Lanka?
Your answer should be very brief. 5.39e+11. In the year 1997, what is the difference between the Exports (in Local Currency Unit) in Fiji and Exports (in Local Currency Unit) in Luxembourg?
Provide a short and direct response. -1.87e+1. In the year 1997, what is the difference between the Exports (in Local Currency Unit) in Fiji and Exports (in Local Currency Unit) in Mexico?
Keep it short and to the point. -9.58e+11. In the year 1997, what is the difference between the Exports (in Local Currency Unit) of Fiji and Exports (in Local Currency Unit) of Sri Lanka?
Your answer should be very brief. -3.23e+11. In the year 1997, what is the difference between the Exports (in Local Currency Unit) of Luxembourg and Exports (in Local Currency Unit) of Mexico?
Make the answer very short. -9.40e+11. In the year 1997, what is the difference between the Exports (in Local Currency Unit) of Luxembourg and Exports (in Local Currency Unit) of Sri Lanka?
Provide a short and direct response. -3.05e+11. In the year 1997, what is the difference between the Exports (in Local Currency Unit) in Mexico and Exports (in Local Currency Unit) in Sri Lanka?
Give a very brief answer. 6.35e+11. In the year 1998, what is the difference between the Exports (in Local Currency Unit) in Fiji and Exports (in Local Currency Unit) in Luxembourg?
Ensure brevity in your answer.  -2.10e+1. In the year 1998, what is the difference between the Exports (in Local Currency Unit) of Fiji and Exports (in Local Currency Unit) of Mexico?
Provide a short and direct response. -1.18e+12. In the year 1998, what is the difference between the Exports (in Local Currency Unit) of Fiji and Exports (in Local Currency Unit) of Sri Lanka?
Provide a succinct answer. -3.67e+11. In the year 1998, what is the difference between the Exports (in Local Currency Unit) of Luxembourg and Exports (in Local Currency Unit) of Mexico?
Ensure brevity in your answer.  -1.16e+12. In the year 1998, what is the difference between the Exports (in Local Currency Unit) of Luxembourg and Exports (in Local Currency Unit) of Sri Lanka?
Ensure brevity in your answer.  -3.46e+11. In the year 1998, what is the difference between the Exports (in Local Currency Unit) in Mexico and Exports (in Local Currency Unit) in Sri Lanka?
Make the answer very short. 8.12e+11. In the year 1999, what is the difference between the Exports (in Local Currency Unit) of Fiji and Exports (in Local Currency Unit) of Luxembourg?
Offer a very short reply. -2.53e+1. In the year 1999, what is the difference between the Exports (in Local Currency Unit) of Fiji and Exports (in Local Currency Unit) of Mexico?
Your response must be concise. -1.41e+12. In the year 1999, what is the difference between the Exports (in Local Currency Unit) in Fiji and Exports (in Local Currency Unit) in Sri Lanka?
Make the answer very short. -3.90e+11. In the year 1999, what is the difference between the Exports (in Local Currency Unit) of Luxembourg and Exports (in Local Currency Unit) of Mexico?
Ensure brevity in your answer.  -1.38e+12. In the year 1999, what is the difference between the Exports (in Local Currency Unit) in Luxembourg and Exports (in Local Currency Unit) in Sri Lanka?
Ensure brevity in your answer.  -3.65e+11. In the year 1999, what is the difference between the Exports (in Local Currency Unit) of Mexico and Exports (in Local Currency Unit) of Sri Lanka?
Your answer should be compact. 1.02e+12. In the year 2000, what is the difference between the Exports (in Local Currency Unit) of Fiji and Exports (in Local Currency Unit) of Luxembourg?
Keep it short and to the point. -3.19e+1. In the year 2000, what is the difference between the Exports (in Local Currency Unit) in Fiji and Exports (in Local Currency Unit) in Mexico?
Keep it short and to the point. -1.70e+12. In the year 2000, what is the difference between the Exports (in Local Currency Unit) in Fiji and Exports (in Local Currency Unit) in Sri Lanka?
Your answer should be compact. -4.88e+11. In the year 2000, what is the difference between the Exports (in Local Currency Unit) in Luxembourg and Exports (in Local Currency Unit) in Mexico?
Give a very brief answer. -1.66e+12. In the year 2000, what is the difference between the Exports (in Local Currency Unit) in Luxembourg and Exports (in Local Currency Unit) in Sri Lanka?
Make the answer very short. -4.56e+11. In the year 2000, what is the difference between the Exports (in Local Currency Unit) in Mexico and Exports (in Local Currency Unit) in Sri Lanka?
Your response must be concise. 1.21e+12. In the year 2001, what is the difference between the Exports (in Local Currency Unit) of Fiji and Exports (in Local Currency Unit) of Luxembourg?
Provide a short and direct response. -3.27e+1. In the year 2001, what is the difference between the Exports (in Local Currency Unit) of Fiji and Exports (in Local Currency Unit) of Mexico?
Your answer should be very brief. -1.60e+12. In the year 2001, what is the difference between the Exports (in Local Currency Unit) in Fiji and Exports (in Local Currency Unit) in Sri Lanka?
Your answer should be compact. -5.23e+11. In the year 2001, what is the difference between the Exports (in Local Currency Unit) of Luxembourg and Exports (in Local Currency Unit) of Mexico?
Your response must be concise. -1.57e+12. In the year 2001, what is the difference between the Exports (in Local Currency Unit) of Luxembourg and Exports (in Local Currency Unit) of Sri Lanka?
Keep it short and to the point. -4.90e+11. In the year 2001, what is the difference between the Exports (in Local Currency Unit) of Mexico and Exports (in Local Currency Unit) of Sri Lanka?
Offer a terse response. 1.08e+12. What is the ratio of the Exports (in Local Currency Unit) of Fiji in 1994 to that in 1995?
Your answer should be compact. 0.92. What is the ratio of the Exports (in Local Currency Unit) in Luxembourg in 1994 to that in 1995?
Offer a terse response. 0.94. What is the ratio of the Exports (in Local Currency Unit) in Mexico in 1994 to that in 1995?
Give a very brief answer. 0.43. What is the ratio of the Exports (in Local Currency Unit) in Sri Lanka in 1994 to that in 1995?
Your response must be concise. 0.82. What is the ratio of the Exports (in Local Currency Unit) of Fiji in 1994 to that in 1996?
Your answer should be very brief. 0.8. What is the ratio of the Exports (in Local Currency Unit) in Luxembourg in 1994 to that in 1996?
Offer a very short reply. 0.86. What is the ratio of the Exports (in Local Currency Unit) of Mexico in 1994 to that in 1996?
Provide a short and direct response. 0.29. What is the ratio of the Exports (in Local Currency Unit) in Sri Lanka in 1994 to that in 1996?
Provide a succinct answer. 0.73. What is the ratio of the Exports (in Local Currency Unit) of Fiji in 1994 to that in 1997?
Offer a very short reply. 0.82. What is the ratio of the Exports (in Local Currency Unit) in Luxembourg in 1994 to that in 1997?
Give a very brief answer. 0.76. What is the ratio of the Exports (in Local Currency Unit) in Mexico in 1994 to that in 1997?
Provide a short and direct response. 0.25. What is the ratio of the Exports (in Local Currency Unit) in Sri Lanka in 1994 to that in 1997?
Provide a short and direct response. 0.6. What is the ratio of the Exports (in Local Currency Unit) of Fiji in 1994 to that in 1998?
Provide a succinct answer. 0.75. What is the ratio of the Exports (in Local Currency Unit) in Luxembourg in 1994 to that in 1998?
Provide a succinct answer. 0.68. What is the ratio of the Exports (in Local Currency Unit) of Mexico in 1994 to that in 1998?
Keep it short and to the point. 0.2. What is the ratio of the Exports (in Local Currency Unit) of Sri Lanka in 1994 to that in 1998?
Offer a very short reply. 0.53. What is the ratio of the Exports (in Local Currency Unit) in Fiji in 1994 to that in 1999?
Give a very brief answer. 0.65. What is the ratio of the Exports (in Local Currency Unit) of Luxembourg in 1994 to that in 1999?
Give a very brief answer. 0.57. What is the ratio of the Exports (in Local Currency Unit) in Mexico in 1994 to that in 1999?
Your answer should be very brief. 0.17. What is the ratio of the Exports (in Local Currency Unit) in Sri Lanka in 1994 to that in 1999?
Your answer should be very brief. 0.5. What is the ratio of the Exports (in Local Currency Unit) in Fiji in 1994 to that in 2000?
Keep it short and to the point. 0.65. What is the ratio of the Exports (in Local Currency Unit) of Luxembourg in 1994 to that in 2000?
Offer a terse response. 0.46. What is the ratio of the Exports (in Local Currency Unit) of Mexico in 1994 to that in 2000?
Your response must be concise. 0.14. What is the ratio of the Exports (in Local Currency Unit) of Sri Lanka in 1994 to that in 2000?
Provide a short and direct response. 0.4. What is the ratio of the Exports (in Local Currency Unit) of Fiji in 1994 to that in 2001?
Give a very brief answer. 0.66. What is the ratio of the Exports (in Local Currency Unit) in Luxembourg in 1994 to that in 2001?
Keep it short and to the point. 0.45. What is the ratio of the Exports (in Local Currency Unit) of Mexico in 1994 to that in 2001?
Offer a very short reply. 0.15. What is the ratio of the Exports (in Local Currency Unit) in Sri Lanka in 1994 to that in 2001?
Provide a succinct answer. 0.37. What is the ratio of the Exports (in Local Currency Unit) of Fiji in 1995 to that in 1996?
Your answer should be compact. 0.87. What is the ratio of the Exports (in Local Currency Unit) in Luxembourg in 1995 to that in 1996?
Give a very brief answer. 0.92. What is the ratio of the Exports (in Local Currency Unit) of Mexico in 1995 to that in 1996?
Offer a very short reply. 0.69. What is the ratio of the Exports (in Local Currency Unit) of Sri Lanka in 1995 to that in 1996?
Keep it short and to the point. 0.88. What is the ratio of the Exports (in Local Currency Unit) in Fiji in 1995 to that in 1997?
Keep it short and to the point. 0.89. What is the ratio of the Exports (in Local Currency Unit) of Luxembourg in 1995 to that in 1997?
Keep it short and to the point. 0.81. What is the ratio of the Exports (in Local Currency Unit) in Mexico in 1995 to that in 1997?
Give a very brief answer. 0.58. What is the ratio of the Exports (in Local Currency Unit) of Sri Lanka in 1995 to that in 1997?
Ensure brevity in your answer.  0.73. What is the ratio of the Exports (in Local Currency Unit) of Fiji in 1995 to that in 1998?
Your answer should be compact. 0.82. What is the ratio of the Exports (in Local Currency Unit) in Luxembourg in 1995 to that in 1998?
Give a very brief answer. 0.72. What is the ratio of the Exports (in Local Currency Unit) in Mexico in 1995 to that in 1998?
Provide a succinct answer. 0.47. What is the ratio of the Exports (in Local Currency Unit) in Sri Lanka in 1995 to that in 1998?
Your answer should be compact. 0.64. What is the ratio of the Exports (in Local Currency Unit) in Fiji in 1995 to that in 1999?
Provide a succinct answer. 0.7. What is the ratio of the Exports (in Local Currency Unit) in Luxembourg in 1995 to that in 1999?
Make the answer very short. 0.6. What is the ratio of the Exports (in Local Currency Unit) in Mexico in 1995 to that in 1999?
Keep it short and to the point. 0.39. What is the ratio of the Exports (in Local Currency Unit) in Sri Lanka in 1995 to that in 1999?
Make the answer very short. 0.61. What is the ratio of the Exports (in Local Currency Unit) in Fiji in 1995 to that in 2000?
Make the answer very short. 0.7. What is the ratio of the Exports (in Local Currency Unit) of Luxembourg in 1995 to that in 2000?
Offer a terse response. 0.49. What is the ratio of the Exports (in Local Currency Unit) of Mexico in 1995 to that in 2000?
Your answer should be very brief. 0.33. What is the ratio of the Exports (in Local Currency Unit) in Sri Lanka in 1995 to that in 2000?
Ensure brevity in your answer.  0.48. What is the ratio of the Exports (in Local Currency Unit) in Fiji in 1995 to that in 2001?
Your answer should be very brief. 0.72. What is the ratio of the Exports (in Local Currency Unit) in Luxembourg in 1995 to that in 2001?
Offer a terse response. 0.48. What is the ratio of the Exports (in Local Currency Unit) of Mexico in 1995 to that in 2001?
Provide a short and direct response. 0.35. What is the ratio of the Exports (in Local Currency Unit) in Sri Lanka in 1995 to that in 2001?
Offer a very short reply. 0.45. What is the ratio of the Exports (in Local Currency Unit) in Fiji in 1996 to that in 1997?
Give a very brief answer. 1.02. What is the ratio of the Exports (in Local Currency Unit) of Luxembourg in 1996 to that in 1997?
Your response must be concise. 0.88. What is the ratio of the Exports (in Local Currency Unit) in Mexico in 1996 to that in 1997?
Give a very brief answer. 0.84. What is the ratio of the Exports (in Local Currency Unit) of Sri Lanka in 1996 to that in 1997?
Your answer should be very brief. 0.83. What is the ratio of the Exports (in Local Currency Unit) of Fiji in 1996 to that in 1998?
Ensure brevity in your answer.  0.94. What is the ratio of the Exports (in Local Currency Unit) in Luxembourg in 1996 to that in 1998?
Your answer should be very brief. 0.79. What is the ratio of the Exports (in Local Currency Unit) of Mexico in 1996 to that in 1998?
Your answer should be compact. 0.68. What is the ratio of the Exports (in Local Currency Unit) in Sri Lanka in 1996 to that in 1998?
Make the answer very short. 0.73. What is the ratio of the Exports (in Local Currency Unit) in Fiji in 1996 to that in 1999?
Make the answer very short. 0.8. What is the ratio of the Exports (in Local Currency Unit) of Luxembourg in 1996 to that in 1999?
Give a very brief answer. 0.66. What is the ratio of the Exports (in Local Currency Unit) in Mexico in 1996 to that in 1999?
Give a very brief answer. 0.57. What is the ratio of the Exports (in Local Currency Unit) in Sri Lanka in 1996 to that in 1999?
Provide a succinct answer. 0.68. What is the ratio of the Exports (in Local Currency Unit) of Fiji in 1996 to that in 2000?
Make the answer very short. 0.8. What is the ratio of the Exports (in Local Currency Unit) in Luxembourg in 1996 to that in 2000?
Offer a terse response. 0.53. What is the ratio of the Exports (in Local Currency Unit) in Mexico in 1996 to that in 2000?
Your answer should be compact. 0.48. What is the ratio of the Exports (in Local Currency Unit) of Sri Lanka in 1996 to that in 2000?
Provide a short and direct response. 0.55. What is the ratio of the Exports (in Local Currency Unit) in Fiji in 1996 to that in 2001?
Provide a succinct answer. 0.82. What is the ratio of the Exports (in Local Currency Unit) in Luxembourg in 1996 to that in 2001?
Keep it short and to the point. 0.52. What is the ratio of the Exports (in Local Currency Unit) in Mexico in 1996 to that in 2001?
Your answer should be very brief. 0.5. What is the ratio of the Exports (in Local Currency Unit) in Sri Lanka in 1996 to that in 2001?
Provide a succinct answer. 0.51. What is the ratio of the Exports (in Local Currency Unit) in Fiji in 1997 to that in 1998?
Make the answer very short. 0.92. What is the ratio of the Exports (in Local Currency Unit) in Luxembourg in 1997 to that in 1998?
Provide a short and direct response. 0.89. What is the ratio of the Exports (in Local Currency Unit) in Mexico in 1997 to that in 1998?
Ensure brevity in your answer.  0.81. What is the ratio of the Exports (in Local Currency Unit) in Sri Lanka in 1997 to that in 1998?
Provide a succinct answer. 0.88. What is the ratio of the Exports (in Local Currency Unit) of Fiji in 1997 to that in 1999?
Offer a very short reply. 0.79. What is the ratio of the Exports (in Local Currency Unit) in Luxembourg in 1997 to that in 1999?
Keep it short and to the point. 0.74. What is the ratio of the Exports (in Local Currency Unit) of Mexico in 1997 to that in 1999?
Your answer should be very brief. 0.68. What is the ratio of the Exports (in Local Currency Unit) in Sri Lanka in 1997 to that in 1999?
Your response must be concise. 0.83. What is the ratio of the Exports (in Local Currency Unit) in Fiji in 1997 to that in 2000?
Your response must be concise. 0.79. What is the ratio of the Exports (in Local Currency Unit) of Luxembourg in 1997 to that in 2000?
Provide a short and direct response. 0.6. What is the ratio of the Exports (in Local Currency Unit) of Mexico in 1997 to that in 2000?
Keep it short and to the point. 0.57. What is the ratio of the Exports (in Local Currency Unit) in Sri Lanka in 1997 to that in 2000?
Your response must be concise. 0.66. What is the ratio of the Exports (in Local Currency Unit) of Fiji in 1997 to that in 2001?
Offer a terse response. 0.8. What is the ratio of the Exports (in Local Currency Unit) of Luxembourg in 1997 to that in 2001?
Provide a succinct answer. 0.59. What is the ratio of the Exports (in Local Currency Unit) in Mexico in 1997 to that in 2001?
Make the answer very short. 0.6. What is the ratio of the Exports (in Local Currency Unit) of Sri Lanka in 1997 to that in 2001?
Give a very brief answer. 0.62. What is the ratio of the Exports (in Local Currency Unit) in Fiji in 1998 to that in 1999?
Your answer should be compact. 0.86. What is the ratio of the Exports (in Local Currency Unit) of Luxembourg in 1998 to that in 1999?
Provide a succinct answer. 0.83. What is the ratio of the Exports (in Local Currency Unit) in Mexico in 1998 to that in 1999?
Give a very brief answer. 0.84. What is the ratio of the Exports (in Local Currency Unit) in Sri Lanka in 1998 to that in 1999?
Provide a succinct answer. 0.94. What is the ratio of the Exports (in Local Currency Unit) in Fiji in 1998 to that in 2000?
Offer a very short reply. 0.86. What is the ratio of the Exports (in Local Currency Unit) in Luxembourg in 1998 to that in 2000?
Your answer should be compact. 0.67. What is the ratio of the Exports (in Local Currency Unit) in Mexico in 1998 to that in 2000?
Make the answer very short. 0.7. What is the ratio of the Exports (in Local Currency Unit) of Sri Lanka in 1998 to that in 2000?
Ensure brevity in your answer.  0.75. What is the ratio of the Exports (in Local Currency Unit) of Fiji in 1998 to that in 2001?
Offer a very short reply. 0.87. What is the ratio of the Exports (in Local Currency Unit) of Luxembourg in 1998 to that in 2001?
Your answer should be compact. 0.66. What is the ratio of the Exports (in Local Currency Unit) in Mexico in 1998 to that in 2001?
Give a very brief answer. 0.74. What is the ratio of the Exports (in Local Currency Unit) in Sri Lanka in 1998 to that in 2001?
Your answer should be very brief. 0.7. What is the ratio of the Exports (in Local Currency Unit) of Fiji in 1999 to that in 2000?
Keep it short and to the point. 1. What is the ratio of the Exports (in Local Currency Unit) in Luxembourg in 1999 to that in 2000?
Give a very brief answer. 0.81. What is the ratio of the Exports (in Local Currency Unit) of Mexico in 1999 to that in 2000?
Your response must be concise. 0.83. What is the ratio of the Exports (in Local Currency Unit) in Sri Lanka in 1999 to that in 2000?
Provide a short and direct response. 0.8. What is the ratio of the Exports (in Local Currency Unit) of Luxembourg in 1999 to that in 2001?
Ensure brevity in your answer.  0.79. What is the ratio of the Exports (in Local Currency Unit) of Mexico in 1999 to that in 2001?
Make the answer very short. 0.88. What is the ratio of the Exports (in Local Currency Unit) in Sri Lanka in 1999 to that in 2001?
Provide a short and direct response. 0.75. What is the ratio of the Exports (in Local Currency Unit) of Fiji in 2000 to that in 2001?
Ensure brevity in your answer.  1.02. What is the ratio of the Exports (in Local Currency Unit) of Luxembourg in 2000 to that in 2001?
Provide a succinct answer. 0.98. What is the ratio of the Exports (in Local Currency Unit) of Mexico in 2000 to that in 2001?
Keep it short and to the point. 1.06. What is the ratio of the Exports (in Local Currency Unit) in Sri Lanka in 2000 to that in 2001?
Provide a succinct answer. 0.93. What is the difference between the highest and the second highest Exports (in Local Currency Unit) in Fiji?
Your answer should be very brief. 1.50e+06. What is the difference between the highest and the second highest Exports (in Local Currency Unit) of Luxembourg?
Make the answer very short. 7.67e+08. What is the difference between the highest and the second highest Exports (in Local Currency Unit) in Mexico?
Offer a very short reply. 9.78e+1. What is the difference between the highest and the second highest Exports (in Local Currency Unit) of Sri Lanka?
Offer a terse response. 3.47e+1. What is the difference between the highest and the lowest Exports (in Local Currency Unit) in Fiji?
Provide a succinct answer. 8.28e+08. What is the difference between the highest and the lowest Exports (in Local Currency Unit) of Luxembourg?
Ensure brevity in your answer.  1.93e+1. What is the difference between the highest and the lowest Exports (in Local Currency Unit) of Mexico?
Your response must be concise. 1.46e+12. What is the difference between the highest and the lowest Exports (in Local Currency Unit) of Sri Lanka?
Your answer should be very brief. 3.30e+11. 